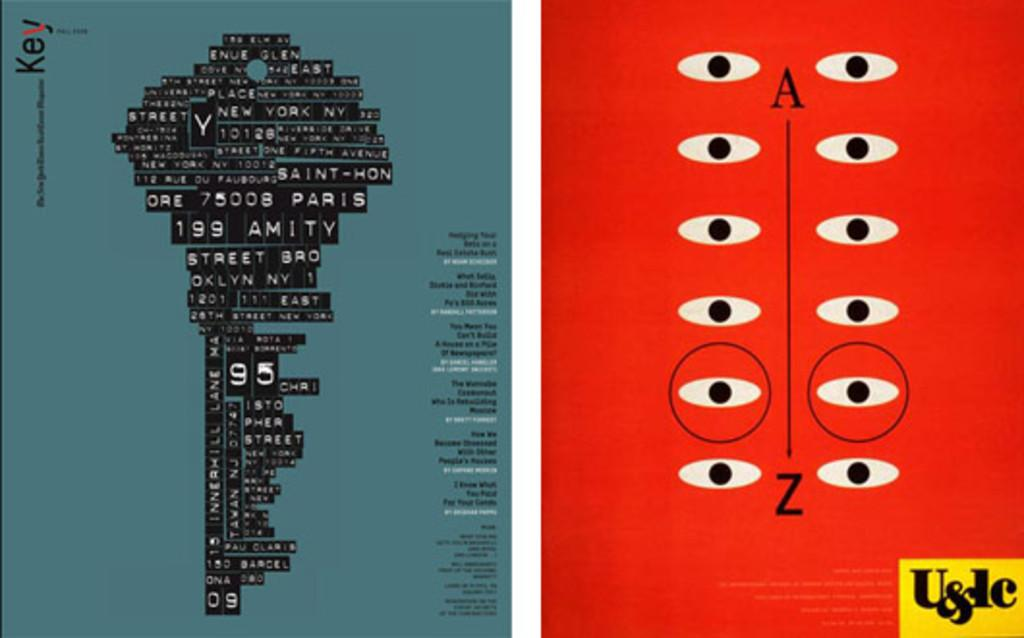Provide a one-sentence caption for the provided image. Two posters that contain Key and  U&dc with New york and eyes. 